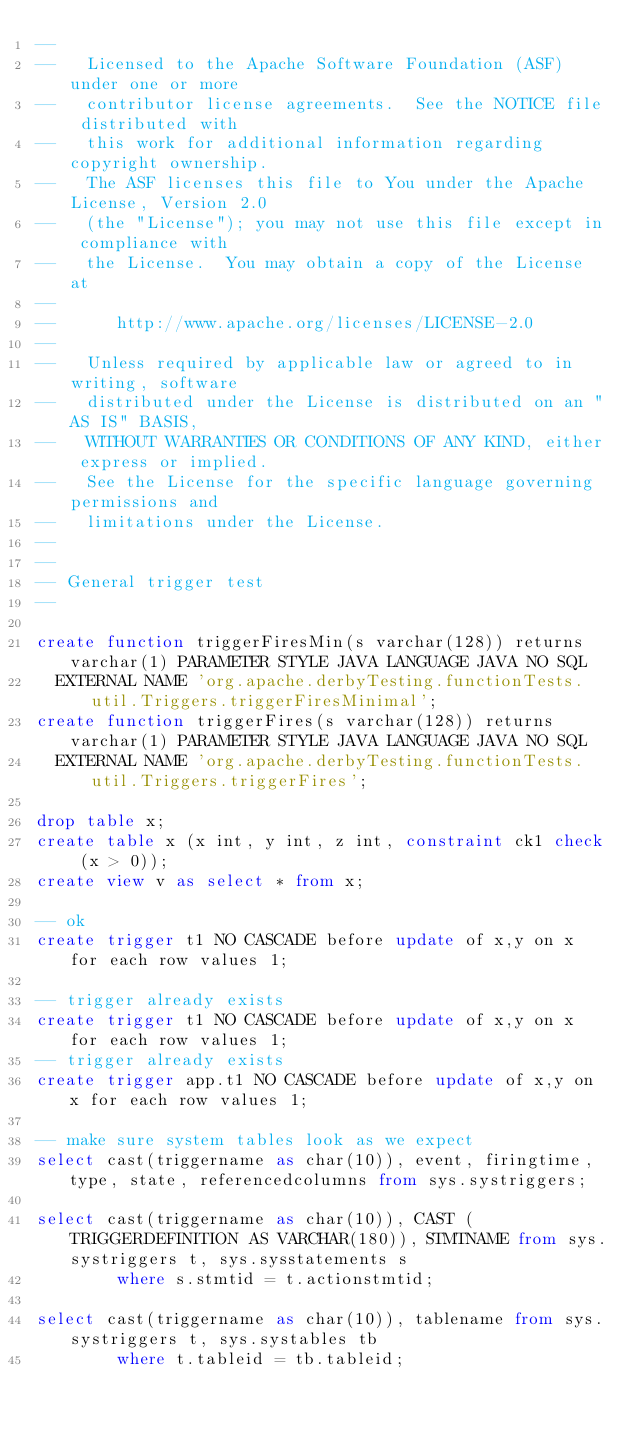Convert code to text. <code><loc_0><loc_0><loc_500><loc_500><_SQL_>--
--   Licensed to the Apache Software Foundation (ASF) under one or more
--   contributor license agreements.  See the NOTICE file distributed with
--   this work for additional information regarding copyright ownership.
--   The ASF licenses this file to You under the Apache License, Version 2.0
--   (the "License"); you may not use this file except in compliance with
--   the License.  You may obtain a copy of the License at
--
--      http://www.apache.org/licenses/LICENSE-2.0
--
--   Unless required by applicable law or agreed to in writing, software
--   distributed under the License is distributed on an "AS IS" BASIS,
--   WITHOUT WARRANTIES OR CONDITIONS OF ANY KIND, either express or implied.
--   See the License for the specific language governing permissions and
--   limitations under the License.
--
--
-- General trigger test
--

create function triggerFiresMin(s varchar(128)) returns varchar(1) PARAMETER STYLE JAVA LANGUAGE JAVA NO SQL
  EXTERNAL NAME 'org.apache.derbyTesting.functionTests.util.Triggers.triggerFiresMinimal';
create function triggerFires(s varchar(128)) returns varchar(1) PARAMETER STYLE JAVA LANGUAGE JAVA NO SQL
  EXTERNAL NAME 'org.apache.derbyTesting.functionTests.util.Triggers.triggerFires';

drop table x;
create table x (x int, y int, z int, constraint ck1 check (x > 0));
create view v as select * from x;

-- ok
create trigger t1 NO CASCADE before update of x,y on x for each row values 1;

-- trigger already exists
create trigger t1 NO CASCADE before update of x,y on x for each row values 1;
-- trigger already exists
create trigger app.t1 NO CASCADE before update of x,y on x for each row values 1;

-- make sure system tables look as we expect
select cast(triggername as char(10)), event, firingtime, type, state, referencedcolumns from sys.systriggers;

select cast(triggername as char(10)), CAST (TRIGGERDEFINITION AS VARCHAR(180)), STMTNAME from sys.systriggers t, sys.sysstatements s 
		where s.stmtid = t.actionstmtid;

select cast(triggername as char(10)), tablename from sys.systriggers t, sys.systables tb
		where t.tableid = tb.tableid;
</code> 